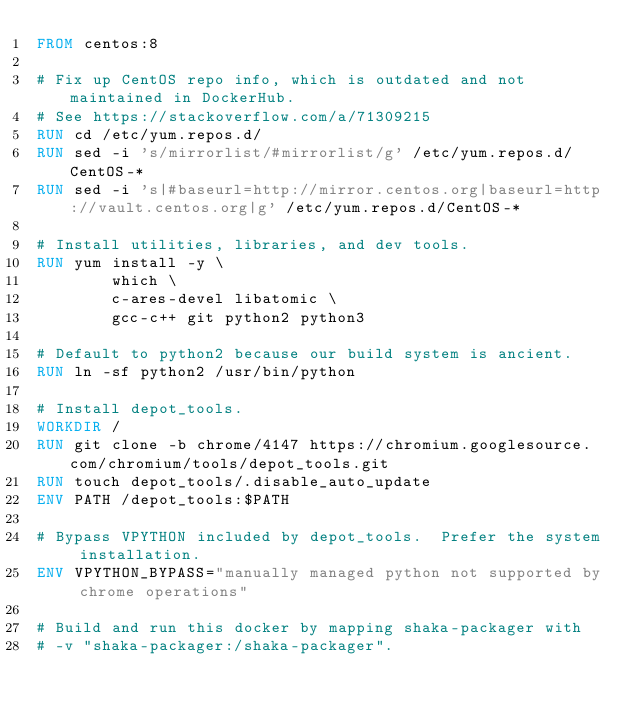<code> <loc_0><loc_0><loc_500><loc_500><_Dockerfile_>FROM centos:8

# Fix up CentOS repo info, which is outdated and not maintained in DockerHub.
# See https://stackoverflow.com/a/71309215
RUN cd /etc/yum.repos.d/
RUN sed -i 's/mirrorlist/#mirrorlist/g' /etc/yum.repos.d/CentOS-*
RUN sed -i 's|#baseurl=http://mirror.centos.org|baseurl=http://vault.centos.org|g' /etc/yum.repos.d/CentOS-*

# Install utilities, libraries, and dev tools.
RUN yum install -y \
        which \
        c-ares-devel libatomic \
        gcc-c++ git python2 python3

# Default to python2 because our build system is ancient.
RUN ln -sf python2 /usr/bin/python

# Install depot_tools.
WORKDIR /
RUN git clone -b chrome/4147 https://chromium.googlesource.com/chromium/tools/depot_tools.git
RUN touch depot_tools/.disable_auto_update
ENV PATH /depot_tools:$PATH

# Bypass VPYTHON included by depot_tools.  Prefer the system installation.
ENV VPYTHON_BYPASS="manually managed python not supported by chrome operations"

# Build and run this docker by mapping shaka-packager with
# -v "shaka-packager:/shaka-packager".
</code> 